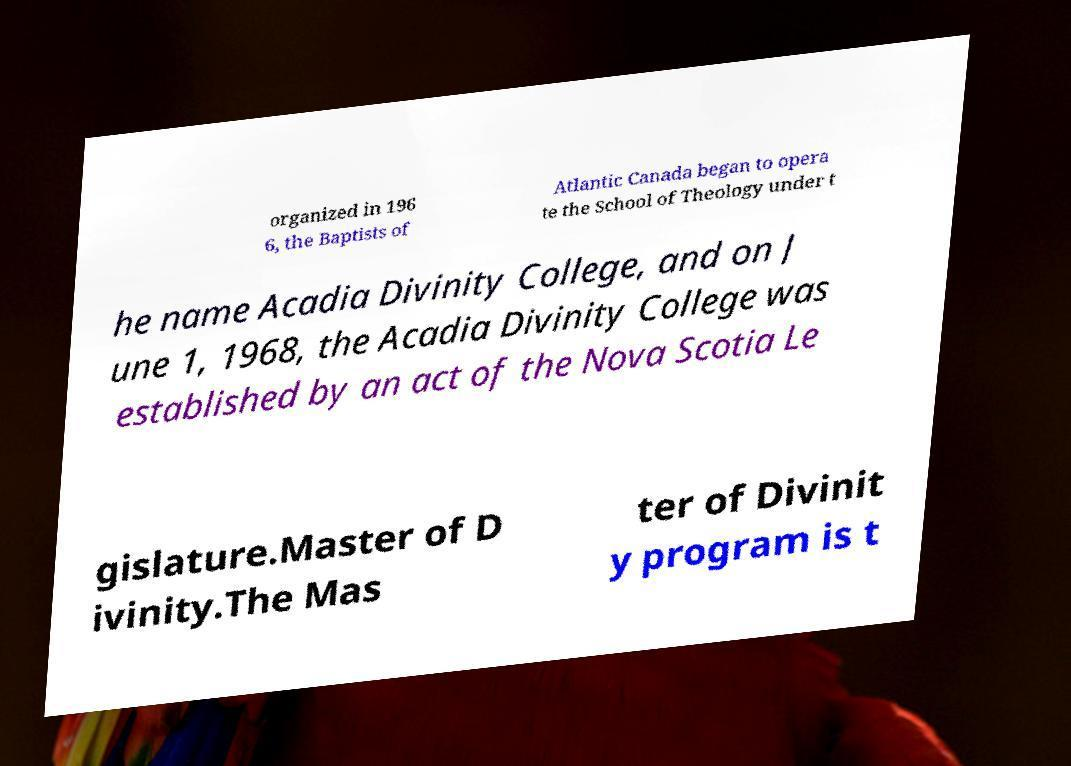For documentation purposes, I need the text within this image transcribed. Could you provide that? organized in 196 6, the Baptists of Atlantic Canada began to opera te the School of Theology under t he name Acadia Divinity College, and on J une 1, 1968, the Acadia Divinity College was established by an act of the Nova Scotia Le gislature.Master of D ivinity.The Mas ter of Divinit y program is t 